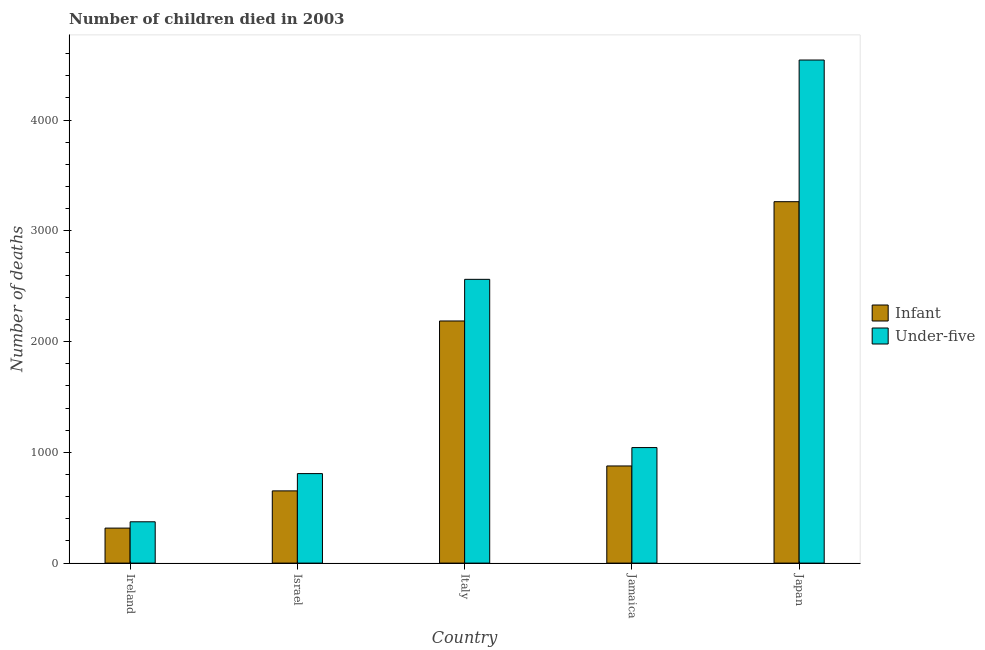How many different coloured bars are there?
Your response must be concise. 2. Are the number of bars per tick equal to the number of legend labels?
Your response must be concise. Yes. Are the number of bars on each tick of the X-axis equal?
Your answer should be compact. Yes. How many bars are there on the 5th tick from the right?
Offer a very short reply. 2. What is the label of the 1st group of bars from the left?
Your response must be concise. Ireland. What is the number of infant deaths in Italy?
Keep it short and to the point. 2186. Across all countries, what is the maximum number of under-five deaths?
Offer a terse response. 4542. Across all countries, what is the minimum number of under-five deaths?
Give a very brief answer. 373. In which country was the number of infant deaths minimum?
Give a very brief answer. Ireland. What is the total number of under-five deaths in the graph?
Keep it short and to the point. 9328. What is the difference between the number of infant deaths in Ireland and that in Israel?
Give a very brief answer. -336. What is the difference between the number of under-five deaths in Japan and the number of infant deaths in Jamaica?
Your answer should be compact. 3665. What is the average number of under-five deaths per country?
Your answer should be very brief. 1865.6. What is the difference between the number of infant deaths and number of under-five deaths in Jamaica?
Give a very brief answer. -166. What is the ratio of the number of infant deaths in Italy to that in Jamaica?
Ensure brevity in your answer.  2.49. What is the difference between the highest and the second highest number of infant deaths?
Provide a short and direct response. 1077. What is the difference between the highest and the lowest number of under-five deaths?
Your response must be concise. 4169. Is the sum of the number of under-five deaths in Ireland and Israel greater than the maximum number of infant deaths across all countries?
Your response must be concise. No. What does the 1st bar from the left in Italy represents?
Keep it short and to the point. Infant. What does the 2nd bar from the right in Israel represents?
Provide a short and direct response. Infant. How many bars are there?
Offer a very short reply. 10. Are all the bars in the graph horizontal?
Keep it short and to the point. No. What is the difference between two consecutive major ticks on the Y-axis?
Your response must be concise. 1000. Does the graph contain any zero values?
Your answer should be compact. No. Does the graph contain grids?
Ensure brevity in your answer.  No. Where does the legend appear in the graph?
Give a very brief answer. Center right. How many legend labels are there?
Offer a terse response. 2. How are the legend labels stacked?
Offer a very short reply. Vertical. What is the title of the graph?
Offer a terse response. Number of children died in 2003. Does "Netherlands" appear as one of the legend labels in the graph?
Your answer should be compact. No. What is the label or title of the X-axis?
Your answer should be very brief. Country. What is the label or title of the Y-axis?
Provide a succinct answer. Number of deaths. What is the Number of deaths of Infant in Ireland?
Provide a succinct answer. 316. What is the Number of deaths of Under-five in Ireland?
Your response must be concise. 373. What is the Number of deaths in Infant in Israel?
Your answer should be very brief. 652. What is the Number of deaths of Under-five in Israel?
Your response must be concise. 808. What is the Number of deaths of Infant in Italy?
Provide a short and direct response. 2186. What is the Number of deaths in Under-five in Italy?
Make the answer very short. 2562. What is the Number of deaths of Infant in Jamaica?
Provide a short and direct response. 877. What is the Number of deaths of Under-five in Jamaica?
Ensure brevity in your answer.  1043. What is the Number of deaths in Infant in Japan?
Keep it short and to the point. 3263. What is the Number of deaths of Under-five in Japan?
Give a very brief answer. 4542. Across all countries, what is the maximum Number of deaths in Infant?
Provide a short and direct response. 3263. Across all countries, what is the maximum Number of deaths of Under-five?
Provide a short and direct response. 4542. Across all countries, what is the minimum Number of deaths of Infant?
Give a very brief answer. 316. Across all countries, what is the minimum Number of deaths of Under-five?
Ensure brevity in your answer.  373. What is the total Number of deaths in Infant in the graph?
Provide a succinct answer. 7294. What is the total Number of deaths in Under-five in the graph?
Your answer should be compact. 9328. What is the difference between the Number of deaths of Infant in Ireland and that in Israel?
Keep it short and to the point. -336. What is the difference between the Number of deaths of Under-five in Ireland and that in Israel?
Your answer should be compact. -435. What is the difference between the Number of deaths of Infant in Ireland and that in Italy?
Give a very brief answer. -1870. What is the difference between the Number of deaths in Under-five in Ireland and that in Italy?
Ensure brevity in your answer.  -2189. What is the difference between the Number of deaths in Infant in Ireland and that in Jamaica?
Provide a short and direct response. -561. What is the difference between the Number of deaths of Under-five in Ireland and that in Jamaica?
Give a very brief answer. -670. What is the difference between the Number of deaths in Infant in Ireland and that in Japan?
Keep it short and to the point. -2947. What is the difference between the Number of deaths in Under-five in Ireland and that in Japan?
Your answer should be very brief. -4169. What is the difference between the Number of deaths of Infant in Israel and that in Italy?
Your response must be concise. -1534. What is the difference between the Number of deaths in Under-five in Israel and that in Italy?
Make the answer very short. -1754. What is the difference between the Number of deaths of Infant in Israel and that in Jamaica?
Offer a terse response. -225. What is the difference between the Number of deaths in Under-five in Israel and that in Jamaica?
Your answer should be very brief. -235. What is the difference between the Number of deaths in Infant in Israel and that in Japan?
Make the answer very short. -2611. What is the difference between the Number of deaths in Under-five in Israel and that in Japan?
Keep it short and to the point. -3734. What is the difference between the Number of deaths in Infant in Italy and that in Jamaica?
Your answer should be compact. 1309. What is the difference between the Number of deaths of Under-five in Italy and that in Jamaica?
Make the answer very short. 1519. What is the difference between the Number of deaths in Infant in Italy and that in Japan?
Offer a terse response. -1077. What is the difference between the Number of deaths of Under-five in Italy and that in Japan?
Offer a terse response. -1980. What is the difference between the Number of deaths in Infant in Jamaica and that in Japan?
Your response must be concise. -2386. What is the difference between the Number of deaths in Under-five in Jamaica and that in Japan?
Your answer should be compact. -3499. What is the difference between the Number of deaths of Infant in Ireland and the Number of deaths of Under-five in Israel?
Your response must be concise. -492. What is the difference between the Number of deaths in Infant in Ireland and the Number of deaths in Under-five in Italy?
Provide a short and direct response. -2246. What is the difference between the Number of deaths of Infant in Ireland and the Number of deaths of Under-five in Jamaica?
Keep it short and to the point. -727. What is the difference between the Number of deaths in Infant in Ireland and the Number of deaths in Under-five in Japan?
Offer a very short reply. -4226. What is the difference between the Number of deaths of Infant in Israel and the Number of deaths of Under-five in Italy?
Keep it short and to the point. -1910. What is the difference between the Number of deaths of Infant in Israel and the Number of deaths of Under-five in Jamaica?
Keep it short and to the point. -391. What is the difference between the Number of deaths of Infant in Israel and the Number of deaths of Under-five in Japan?
Your response must be concise. -3890. What is the difference between the Number of deaths of Infant in Italy and the Number of deaths of Under-five in Jamaica?
Make the answer very short. 1143. What is the difference between the Number of deaths in Infant in Italy and the Number of deaths in Under-five in Japan?
Provide a short and direct response. -2356. What is the difference between the Number of deaths of Infant in Jamaica and the Number of deaths of Under-five in Japan?
Your response must be concise. -3665. What is the average Number of deaths of Infant per country?
Give a very brief answer. 1458.8. What is the average Number of deaths in Under-five per country?
Your answer should be very brief. 1865.6. What is the difference between the Number of deaths of Infant and Number of deaths of Under-five in Ireland?
Give a very brief answer. -57. What is the difference between the Number of deaths of Infant and Number of deaths of Under-five in Israel?
Ensure brevity in your answer.  -156. What is the difference between the Number of deaths in Infant and Number of deaths in Under-five in Italy?
Offer a terse response. -376. What is the difference between the Number of deaths of Infant and Number of deaths of Under-five in Jamaica?
Keep it short and to the point. -166. What is the difference between the Number of deaths in Infant and Number of deaths in Under-five in Japan?
Keep it short and to the point. -1279. What is the ratio of the Number of deaths in Infant in Ireland to that in Israel?
Ensure brevity in your answer.  0.48. What is the ratio of the Number of deaths of Under-five in Ireland to that in Israel?
Provide a succinct answer. 0.46. What is the ratio of the Number of deaths of Infant in Ireland to that in Italy?
Make the answer very short. 0.14. What is the ratio of the Number of deaths in Under-five in Ireland to that in Italy?
Ensure brevity in your answer.  0.15. What is the ratio of the Number of deaths of Infant in Ireland to that in Jamaica?
Your answer should be compact. 0.36. What is the ratio of the Number of deaths of Under-five in Ireland to that in Jamaica?
Give a very brief answer. 0.36. What is the ratio of the Number of deaths in Infant in Ireland to that in Japan?
Offer a very short reply. 0.1. What is the ratio of the Number of deaths of Under-five in Ireland to that in Japan?
Ensure brevity in your answer.  0.08. What is the ratio of the Number of deaths of Infant in Israel to that in Italy?
Provide a succinct answer. 0.3. What is the ratio of the Number of deaths in Under-five in Israel to that in Italy?
Give a very brief answer. 0.32. What is the ratio of the Number of deaths of Infant in Israel to that in Jamaica?
Offer a very short reply. 0.74. What is the ratio of the Number of deaths in Under-five in Israel to that in Jamaica?
Give a very brief answer. 0.77. What is the ratio of the Number of deaths of Infant in Israel to that in Japan?
Offer a terse response. 0.2. What is the ratio of the Number of deaths of Under-five in Israel to that in Japan?
Offer a terse response. 0.18. What is the ratio of the Number of deaths of Infant in Italy to that in Jamaica?
Ensure brevity in your answer.  2.49. What is the ratio of the Number of deaths of Under-five in Italy to that in Jamaica?
Keep it short and to the point. 2.46. What is the ratio of the Number of deaths in Infant in Italy to that in Japan?
Offer a very short reply. 0.67. What is the ratio of the Number of deaths in Under-five in Italy to that in Japan?
Your answer should be compact. 0.56. What is the ratio of the Number of deaths in Infant in Jamaica to that in Japan?
Offer a very short reply. 0.27. What is the ratio of the Number of deaths in Under-five in Jamaica to that in Japan?
Keep it short and to the point. 0.23. What is the difference between the highest and the second highest Number of deaths in Infant?
Provide a short and direct response. 1077. What is the difference between the highest and the second highest Number of deaths in Under-five?
Offer a very short reply. 1980. What is the difference between the highest and the lowest Number of deaths of Infant?
Give a very brief answer. 2947. What is the difference between the highest and the lowest Number of deaths of Under-five?
Ensure brevity in your answer.  4169. 